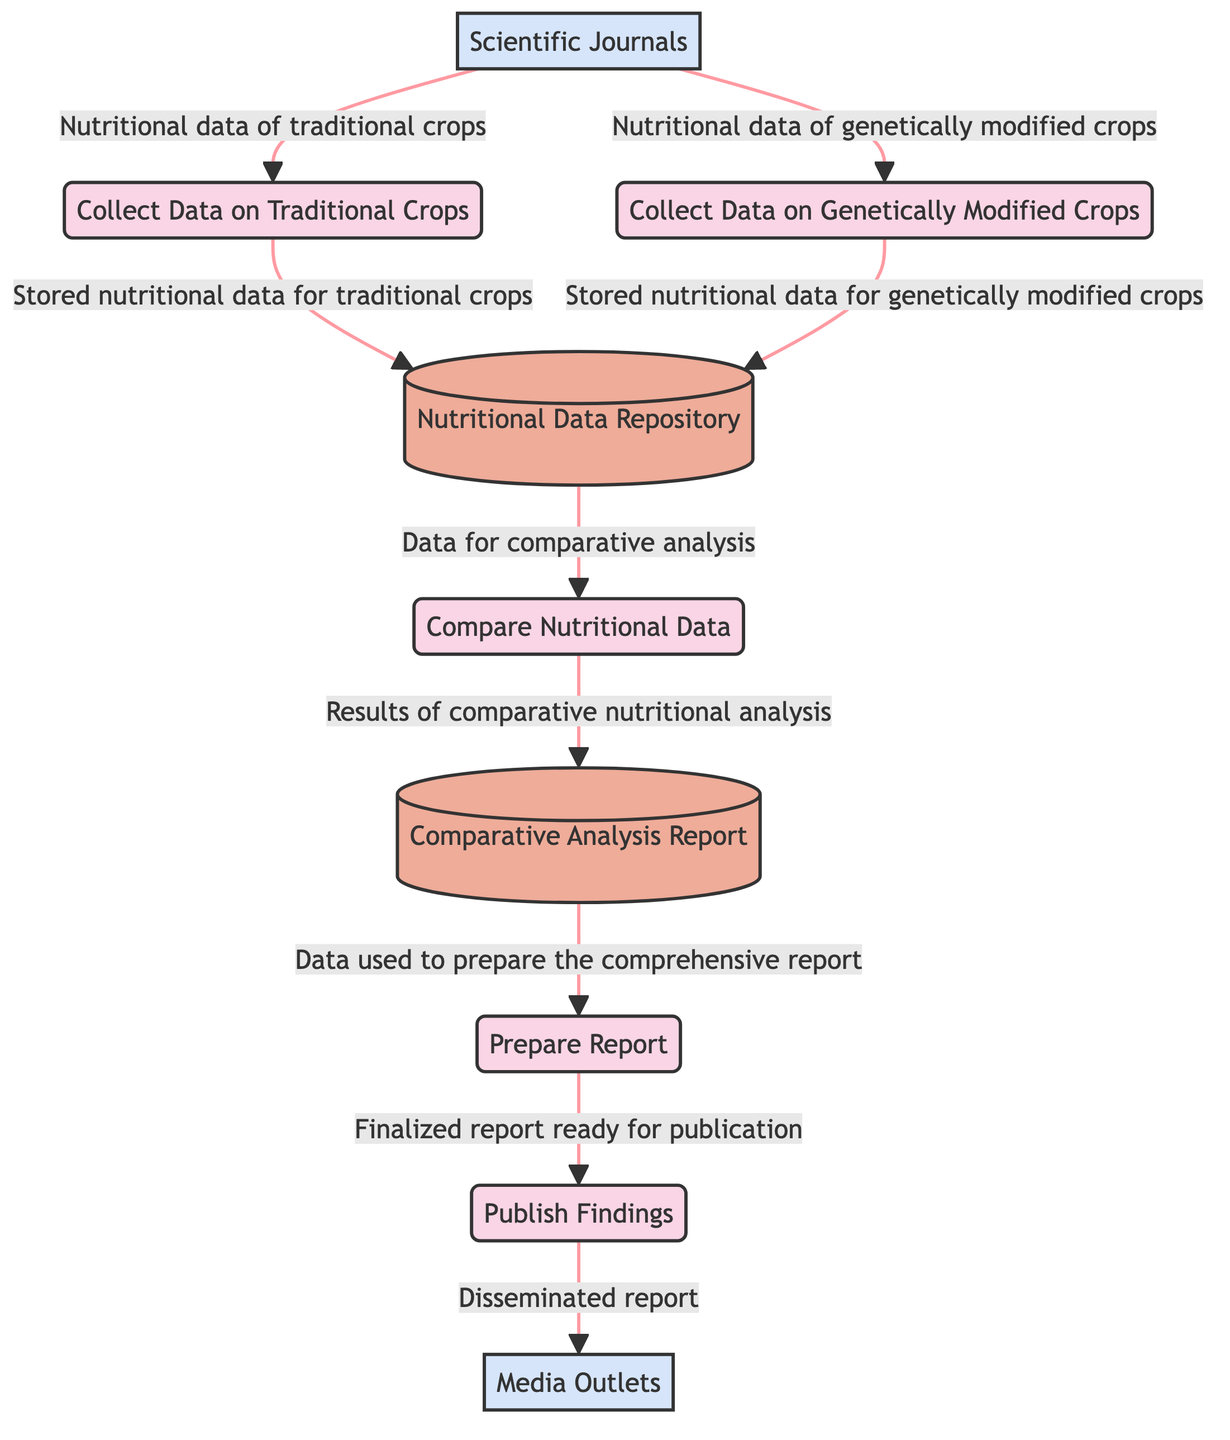What is the first process in the diagram? The diagram starts with the process labeled "Collect Data on Traditional Crops," which is the first step in the analysis.
Answer: Collect Data on Traditional Crops How many processes are present in the diagram? The diagram includes five distinct processes that represent various steps in the comparative analysis.
Answer: 5 What type of data is stored in the Nutritional Data Repository? The Nutritional Data Repository holds the "Stored nutritional data for traditional crops" and "Stored nutritional data for genetically modified crops."
Answer: Nutritional data Which external entity provides data for both traditional and genetically modified crops? "Scientific Journals" is the external entity cited as the source for nutritional data for both types of crops.
Answer: Scientific Journals What is the last process before publishing findings? The last process before publishing findings is "Prepare Report," which involves compiling the results into a comprehensive report.
Answer: Prepare Report What information is sent from the Comparative Analysis Report to the Prepare Report process? The Comparative Analysis Report provides the "Data used to prepare the comprehensive report" to the Prepare Report process.
Answer: Data used to prepare the comprehensive report Which process receives nutritional data specifically for genetically modified crops? The process "Collect Data on Genetically Modified Crops" receives nutritional data from "Scientific Journals."
Answer: Collect Data on Genetically Modified Crops What is the end goal of the Publish Findings process? The end goal of the Publish Findings process is the dissemination of the report to raise public awareness through media platforms.
Answer: Disseminated report How does the data flow from the Nutritional Data Repository to the Comparative Analysis Report? The data flow begins with Nutritional Data Repository providing essential data for "Compare Nutritional Data," which then produces results that are stored in the Comparative Analysis Report.
Answer: Results of comparative nutritional analysis 